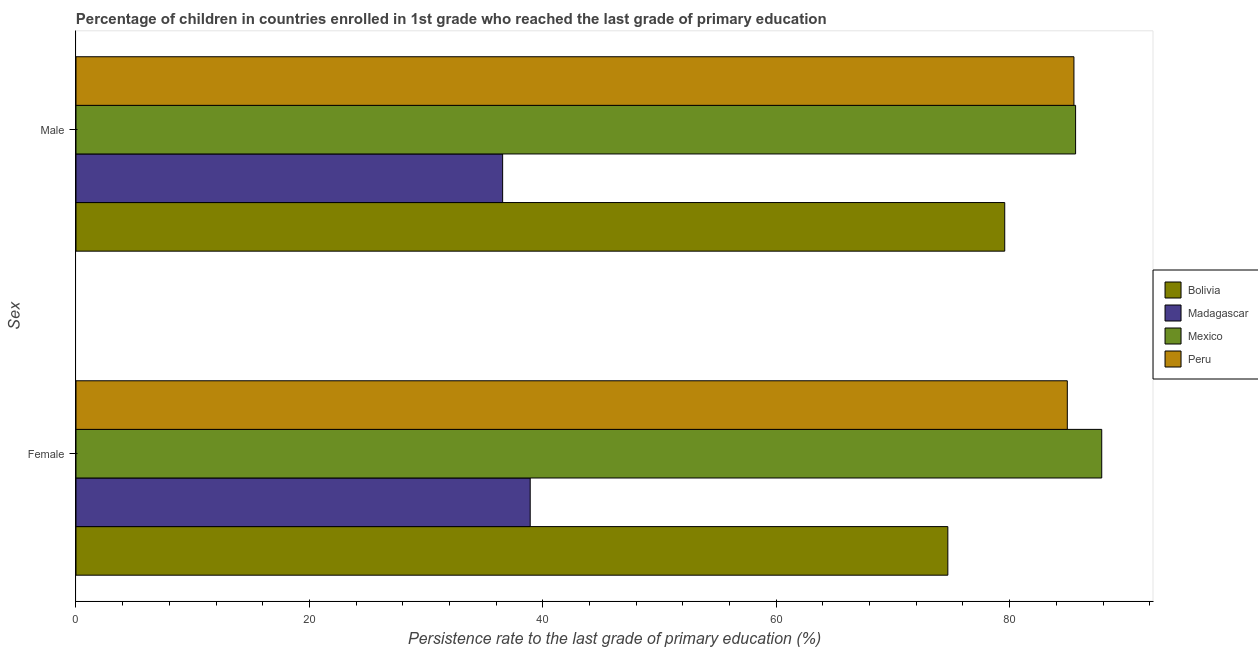How many different coloured bars are there?
Your answer should be very brief. 4. How many groups of bars are there?
Provide a short and direct response. 2. Are the number of bars on each tick of the Y-axis equal?
Make the answer very short. Yes. How many bars are there on the 1st tick from the top?
Ensure brevity in your answer.  4. What is the label of the 1st group of bars from the top?
Offer a terse response. Male. What is the persistence rate of male students in Madagascar?
Your answer should be very brief. 36.56. Across all countries, what is the maximum persistence rate of female students?
Keep it short and to the point. 87.89. Across all countries, what is the minimum persistence rate of male students?
Make the answer very short. 36.56. In which country was the persistence rate of male students minimum?
Provide a succinct answer. Madagascar. What is the total persistence rate of male students in the graph?
Give a very brief answer. 287.3. What is the difference between the persistence rate of female students in Mexico and that in Peru?
Provide a succinct answer. 2.95. What is the difference between the persistence rate of female students in Peru and the persistence rate of male students in Madagascar?
Offer a very short reply. 48.39. What is the average persistence rate of male students per country?
Offer a terse response. 71.83. What is the difference between the persistence rate of female students and persistence rate of male students in Peru?
Provide a short and direct response. -0.57. In how many countries, is the persistence rate of male students greater than 80 %?
Ensure brevity in your answer.  2. What is the ratio of the persistence rate of male students in Peru to that in Madagascar?
Your response must be concise. 2.34. How many bars are there?
Your answer should be very brief. 8. Does the graph contain any zero values?
Give a very brief answer. No. Does the graph contain grids?
Your response must be concise. No. Where does the legend appear in the graph?
Keep it short and to the point. Center right. How many legend labels are there?
Make the answer very short. 4. How are the legend labels stacked?
Your answer should be very brief. Vertical. What is the title of the graph?
Give a very brief answer. Percentage of children in countries enrolled in 1st grade who reached the last grade of primary education. What is the label or title of the X-axis?
Give a very brief answer. Persistence rate to the last grade of primary education (%). What is the label or title of the Y-axis?
Give a very brief answer. Sex. What is the Persistence rate to the last grade of primary education (%) in Bolivia in Female?
Provide a short and direct response. 74.71. What is the Persistence rate to the last grade of primary education (%) in Madagascar in Female?
Your response must be concise. 38.92. What is the Persistence rate to the last grade of primary education (%) in Mexico in Female?
Offer a very short reply. 87.89. What is the Persistence rate to the last grade of primary education (%) of Peru in Female?
Your answer should be compact. 84.94. What is the Persistence rate to the last grade of primary education (%) in Bolivia in Male?
Make the answer very short. 79.58. What is the Persistence rate to the last grade of primary education (%) of Madagascar in Male?
Your answer should be very brief. 36.56. What is the Persistence rate to the last grade of primary education (%) in Mexico in Male?
Offer a terse response. 85.65. What is the Persistence rate to the last grade of primary education (%) in Peru in Male?
Ensure brevity in your answer.  85.51. Across all Sex, what is the maximum Persistence rate to the last grade of primary education (%) of Bolivia?
Provide a succinct answer. 79.58. Across all Sex, what is the maximum Persistence rate to the last grade of primary education (%) of Madagascar?
Your answer should be very brief. 38.92. Across all Sex, what is the maximum Persistence rate to the last grade of primary education (%) of Mexico?
Your answer should be very brief. 87.89. Across all Sex, what is the maximum Persistence rate to the last grade of primary education (%) in Peru?
Give a very brief answer. 85.51. Across all Sex, what is the minimum Persistence rate to the last grade of primary education (%) of Bolivia?
Your response must be concise. 74.71. Across all Sex, what is the minimum Persistence rate to the last grade of primary education (%) in Madagascar?
Your answer should be very brief. 36.56. Across all Sex, what is the minimum Persistence rate to the last grade of primary education (%) in Mexico?
Give a very brief answer. 85.65. Across all Sex, what is the minimum Persistence rate to the last grade of primary education (%) of Peru?
Ensure brevity in your answer.  84.94. What is the total Persistence rate to the last grade of primary education (%) of Bolivia in the graph?
Ensure brevity in your answer.  154.29. What is the total Persistence rate to the last grade of primary education (%) in Madagascar in the graph?
Provide a succinct answer. 75.48. What is the total Persistence rate to the last grade of primary education (%) of Mexico in the graph?
Your answer should be very brief. 173.54. What is the total Persistence rate to the last grade of primary education (%) of Peru in the graph?
Make the answer very short. 170.45. What is the difference between the Persistence rate to the last grade of primary education (%) of Bolivia in Female and that in Male?
Ensure brevity in your answer.  -4.88. What is the difference between the Persistence rate to the last grade of primary education (%) in Madagascar in Female and that in Male?
Your answer should be very brief. 2.36. What is the difference between the Persistence rate to the last grade of primary education (%) of Mexico in Female and that in Male?
Your answer should be compact. 2.24. What is the difference between the Persistence rate to the last grade of primary education (%) in Peru in Female and that in Male?
Provide a short and direct response. -0.57. What is the difference between the Persistence rate to the last grade of primary education (%) in Bolivia in Female and the Persistence rate to the last grade of primary education (%) in Madagascar in Male?
Offer a very short reply. 38.15. What is the difference between the Persistence rate to the last grade of primary education (%) in Bolivia in Female and the Persistence rate to the last grade of primary education (%) in Mexico in Male?
Keep it short and to the point. -10.95. What is the difference between the Persistence rate to the last grade of primary education (%) in Bolivia in Female and the Persistence rate to the last grade of primary education (%) in Peru in Male?
Provide a short and direct response. -10.81. What is the difference between the Persistence rate to the last grade of primary education (%) in Madagascar in Female and the Persistence rate to the last grade of primary education (%) in Mexico in Male?
Ensure brevity in your answer.  -46.73. What is the difference between the Persistence rate to the last grade of primary education (%) of Madagascar in Female and the Persistence rate to the last grade of primary education (%) of Peru in Male?
Your response must be concise. -46.59. What is the difference between the Persistence rate to the last grade of primary education (%) in Mexico in Female and the Persistence rate to the last grade of primary education (%) in Peru in Male?
Make the answer very short. 2.38. What is the average Persistence rate to the last grade of primary education (%) of Bolivia per Sex?
Your response must be concise. 77.14. What is the average Persistence rate to the last grade of primary education (%) of Madagascar per Sex?
Your answer should be compact. 37.74. What is the average Persistence rate to the last grade of primary education (%) of Mexico per Sex?
Your response must be concise. 86.77. What is the average Persistence rate to the last grade of primary education (%) of Peru per Sex?
Your response must be concise. 85.23. What is the difference between the Persistence rate to the last grade of primary education (%) in Bolivia and Persistence rate to the last grade of primary education (%) in Madagascar in Female?
Offer a very short reply. 35.78. What is the difference between the Persistence rate to the last grade of primary education (%) in Bolivia and Persistence rate to the last grade of primary education (%) in Mexico in Female?
Ensure brevity in your answer.  -13.19. What is the difference between the Persistence rate to the last grade of primary education (%) in Bolivia and Persistence rate to the last grade of primary education (%) in Peru in Female?
Offer a very short reply. -10.24. What is the difference between the Persistence rate to the last grade of primary education (%) of Madagascar and Persistence rate to the last grade of primary education (%) of Mexico in Female?
Offer a very short reply. -48.97. What is the difference between the Persistence rate to the last grade of primary education (%) of Madagascar and Persistence rate to the last grade of primary education (%) of Peru in Female?
Offer a terse response. -46.02. What is the difference between the Persistence rate to the last grade of primary education (%) in Mexico and Persistence rate to the last grade of primary education (%) in Peru in Female?
Ensure brevity in your answer.  2.95. What is the difference between the Persistence rate to the last grade of primary education (%) of Bolivia and Persistence rate to the last grade of primary education (%) of Madagascar in Male?
Offer a very short reply. 43.02. What is the difference between the Persistence rate to the last grade of primary education (%) in Bolivia and Persistence rate to the last grade of primary education (%) in Mexico in Male?
Your response must be concise. -6.07. What is the difference between the Persistence rate to the last grade of primary education (%) of Bolivia and Persistence rate to the last grade of primary education (%) of Peru in Male?
Make the answer very short. -5.93. What is the difference between the Persistence rate to the last grade of primary education (%) in Madagascar and Persistence rate to the last grade of primary education (%) in Mexico in Male?
Keep it short and to the point. -49.09. What is the difference between the Persistence rate to the last grade of primary education (%) of Madagascar and Persistence rate to the last grade of primary education (%) of Peru in Male?
Ensure brevity in your answer.  -48.95. What is the difference between the Persistence rate to the last grade of primary education (%) of Mexico and Persistence rate to the last grade of primary education (%) of Peru in Male?
Make the answer very short. 0.14. What is the ratio of the Persistence rate to the last grade of primary education (%) of Bolivia in Female to that in Male?
Your response must be concise. 0.94. What is the ratio of the Persistence rate to the last grade of primary education (%) of Madagascar in Female to that in Male?
Provide a short and direct response. 1.06. What is the ratio of the Persistence rate to the last grade of primary education (%) in Mexico in Female to that in Male?
Provide a short and direct response. 1.03. What is the ratio of the Persistence rate to the last grade of primary education (%) of Peru in Female to that in Male?
Offer a terse response. 0.99. What is the difference between the highest and the second highest Persistence rate to the last grade of primary education (%) in Bolivia?
Provide a short and direct response. 4.88. What is the difference between the highest and the second highest Persistence rate to the last grade of primary education (%) of Madagascar?
Provide a succinct answer. 2.36. What is the difference between the highest and the second highest Persistence rate to the last grade of primary education (%) of Mexico?
Ensure brevity in your answer.  2.24. What is the difference between the highest and the second highest Persistence rate to the last grade of primary education (%) in Peru?
Provide a succinct answer. 0.57. What is the difference between the highest and the lowest Persistence rate to the last grade of primary education (%) of Bolivia?
Provide a succinct answer. 4.88. What is the difference between the highest and the lowest Persistence rate to the last grade of primary education (%) of Madagascar?
Offer a terse response. 2.36. What is the difference between the highest and the lowest Persistence rate to the last grade of primary education (%) of Mexico?
Your answer should be very brief. 2.24. What is the difference between the highest and the lowest Persistence rate to the last grade of primary education (%) of Peru?
Your response must be concise. 0.57. 